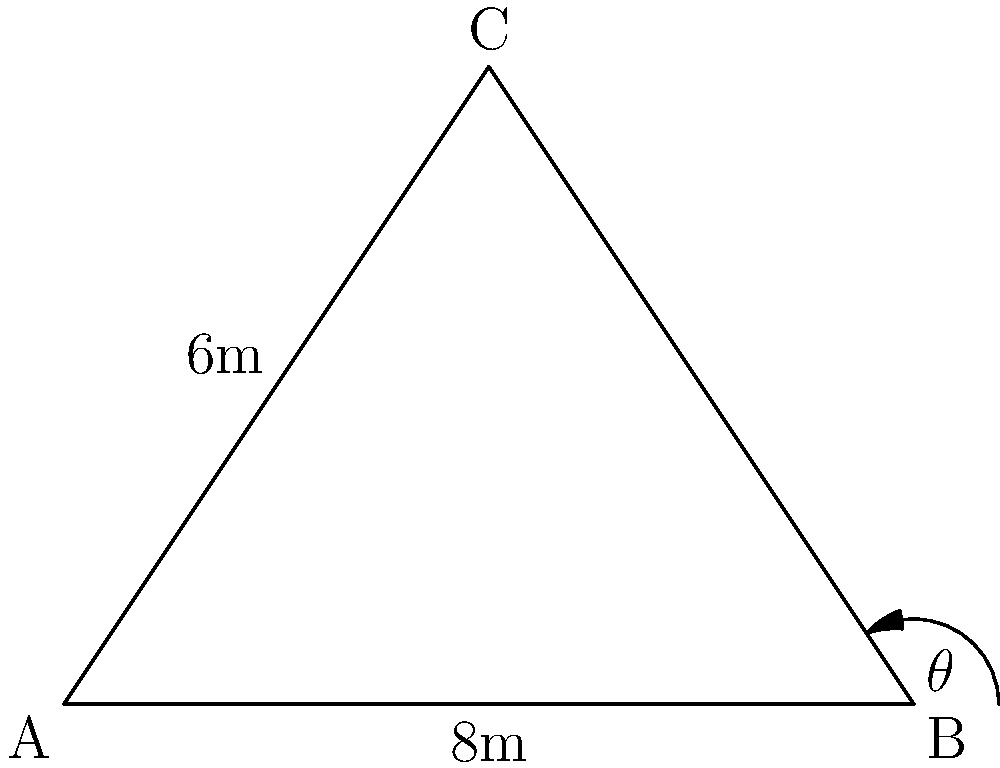In a famous scene from Alfred Hitchcock's "Vertigo," the camera is set up in a triangular layout. The base of the triangle (AB) is 8 meters, and the perpendicular height (from C to AB) is 6 meters. What is the angle $\theta$ of the camera shot from point B to point C? To solve this problem, we'll use trigonometry:

1) First, we need to find the length of BC. We can do this using the Pythagorean theorem:
   $BC^2 = 4^2 + 6^2 = 16 + 36 = 52$
   $BC = \sqrt{52} \approx 7.21$ meters

2) Now we have a right triangle with:
   - The hypotenuse (BC) ≈ 7.21 meters
   - The adjacent side (half of AB) = 4 meters

3) We can use the cosine function to find the angle $\theta$:
   $\cos(\theta) = \frac{\text{adjacent}}{\text{hypotenuse}} = \frac{4}{7.21}$

4) To get $\theta$, we take the inverse cosine (arccos):
   $\theta = \arccos(\frac{4}{7.21})$

5) Calculate this value:
   $\theta \approx 56.3°$

This angle represents the tilt of the camera from the horizontal, creating the dynamic and disorienting effect Hitchcock was famous for in his films.
Answer: $56.3°$ 